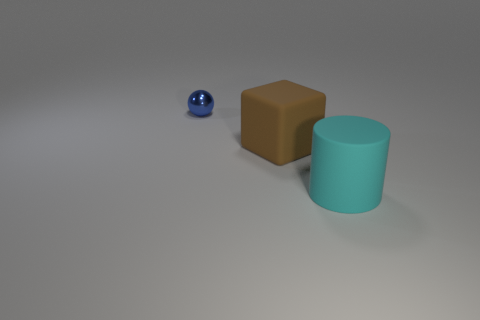Is the material of the thing to the left of the brown object the same as the large cylinder?
Ensure brevity in your answer.  No. What number of objects are red shiny balls or objects?
Provide a short and direct response. 3. The cyan rubber cylinder is what size?
Offer a terse response. Large. Are there more small blue things behind the blue object than tiny spheres?
Your answer should be compact. No. Is there any other thing that is made of the same material as the cyan cylinder?
Offer a terse response. Yes. There is a object behind the big brown thing; is it the same color as the big matte object that is on the left side of the cyan cylinder?
Your response must be concise. No. What material is the large object to the left of the big matte object on the right side of the rubber object that is left of the cyan rubber cylinder made of?
Give a very brief answer. Rubber. Is the number of large cubes greater than the number of large blue spheres?
Provide a succinct answer. Yes. Are there any other things that are the same color as the metal object?
Offer a terse response. No. The cube that is the same material as the big cyan object is what size?
Provide a short and direct response. Large. 